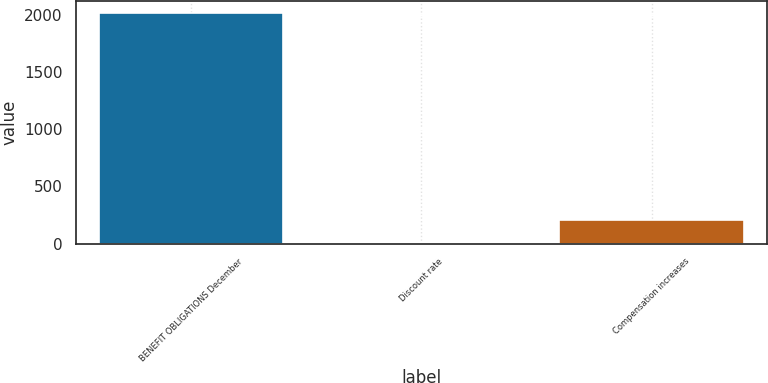<chart> <loc_0><loc_0><loc_500><loc_500><bar_chart><fcel>BENEFIT OBLIGATIONS December<fcel>Discount rate<fcel>Compensation increases<nl><fcel>2018<fcel>2.81<fcel>204.33<nl></chart> 